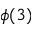Convert formula to latex. <formula><loc_0><loc_0><loc_500><loc_500>\phi ( 3 )</formula> 